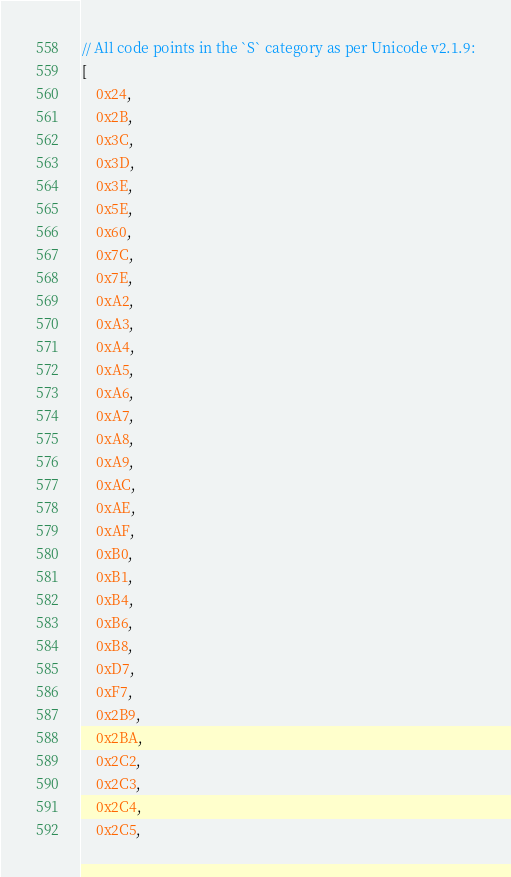Convert code to text. <code><loc_0><loc_0><loc_500><loc_500><_JavaScript_>// All code points in the `S` category as per Unicode v2.1.9:
[
	0x24,
	0x2B,
	0x3C,
	0x3D,
	0x3E,
	0x5E,
	0x60,
	0x7C,
	0x7E,
	0xA2,
	0xA3,
	0xA4,
	0xA5,
	0xA6,
	0xA7,
	0xA8,
	0xA9,
	0xAC,
	0xAE,
	0xAF,
	0xB0,
	0xB1,
	0xB4,
	0xB6,
	0xB8,
	0xD7,
	0xF7,
	0x2B9,
	0x2BA,
	0x2C2,
	0x2C3,
	0x2C4,
	0x2C5,</code> 